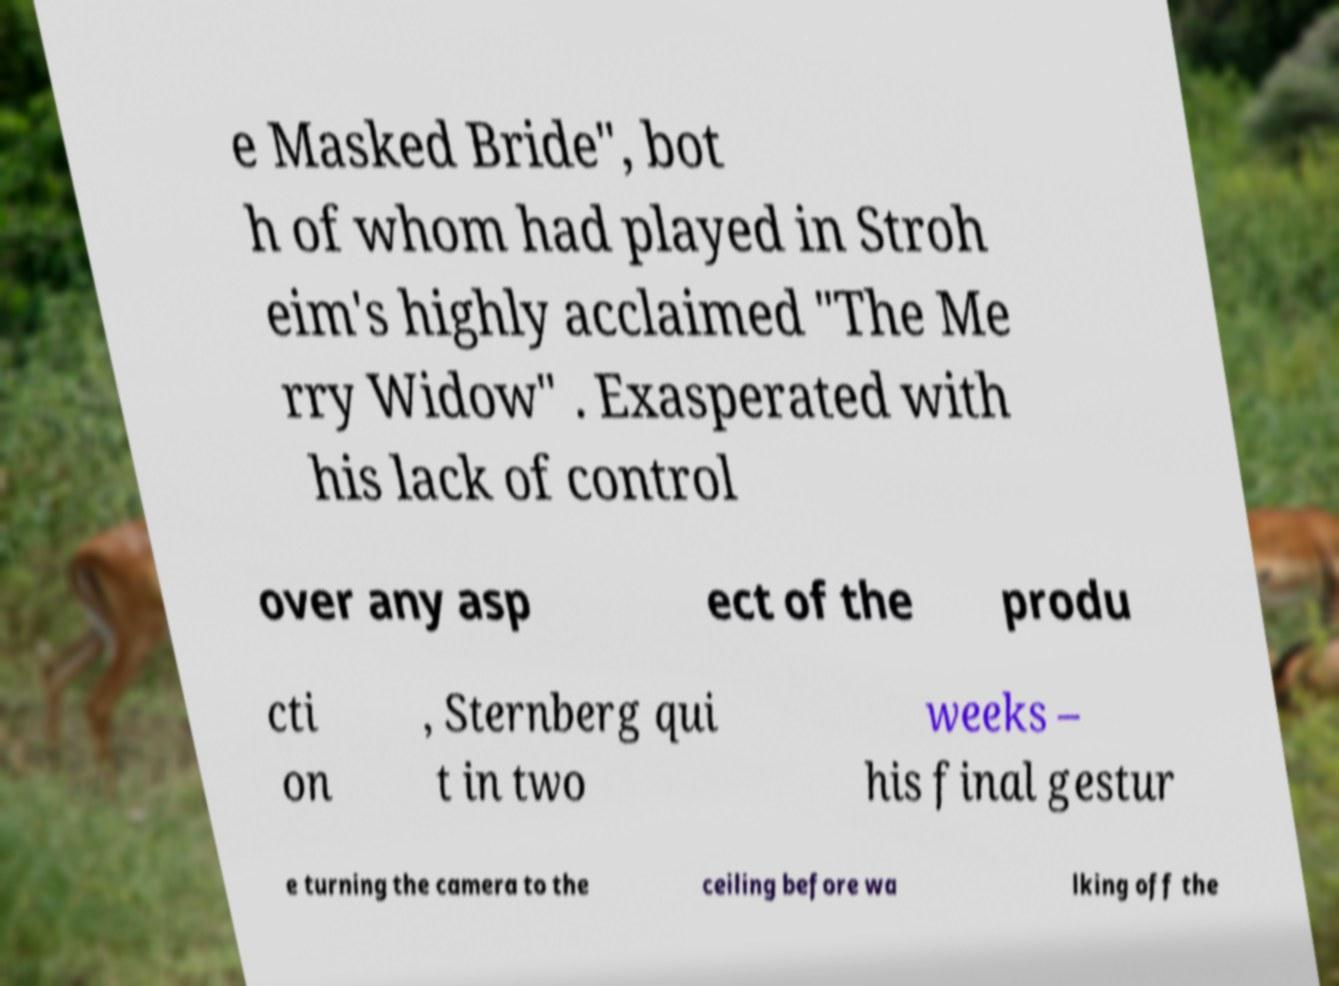For documentation purposes, I need the text within this image transcribed. Could you provide that? e Masked Bride", bot h of whom had played in Stroh eim's highly acclaimed "The Me rry Widow" . Exasperated with his lack of control over any asp ect of the produ cti on , Sternberg qui t in two weeks – his final gestur e turning the camera to the ceiling before wa lking off the 